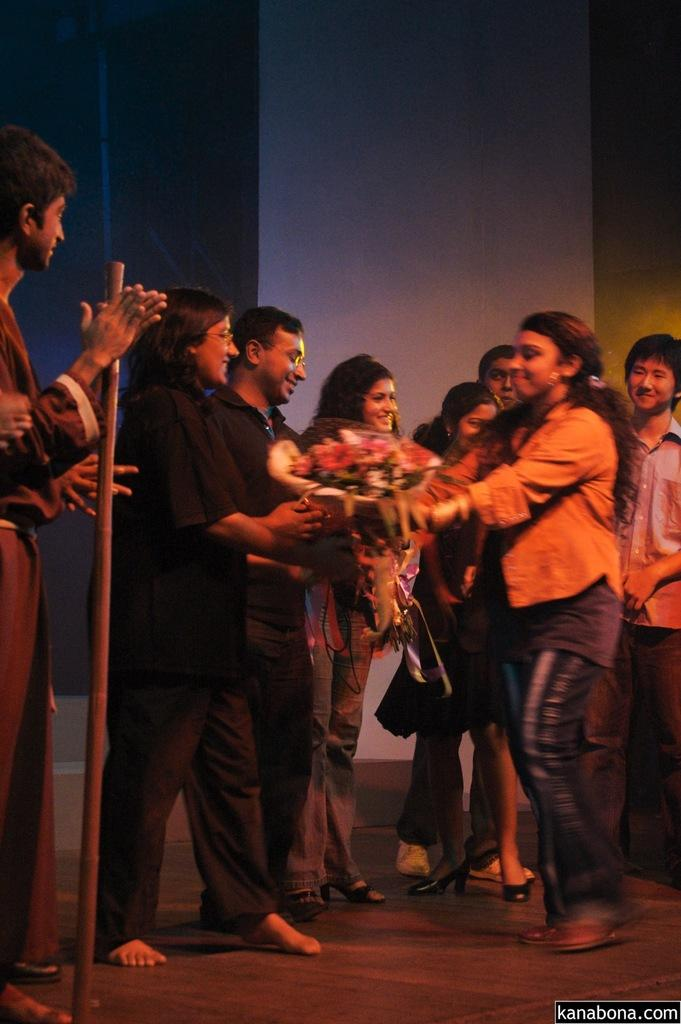What is happening on the stage in the image? There are people standing on the stage in the image. Can you describe what one of the people is holding? A woman is holding a flower bouquet in her hand. What type of polish is being applied to the fork in the image? There is no fork or polish present in the image. What kind of structure is being built on the stage? There is no structure being built on the stage in the image; it only shows people standing there. 